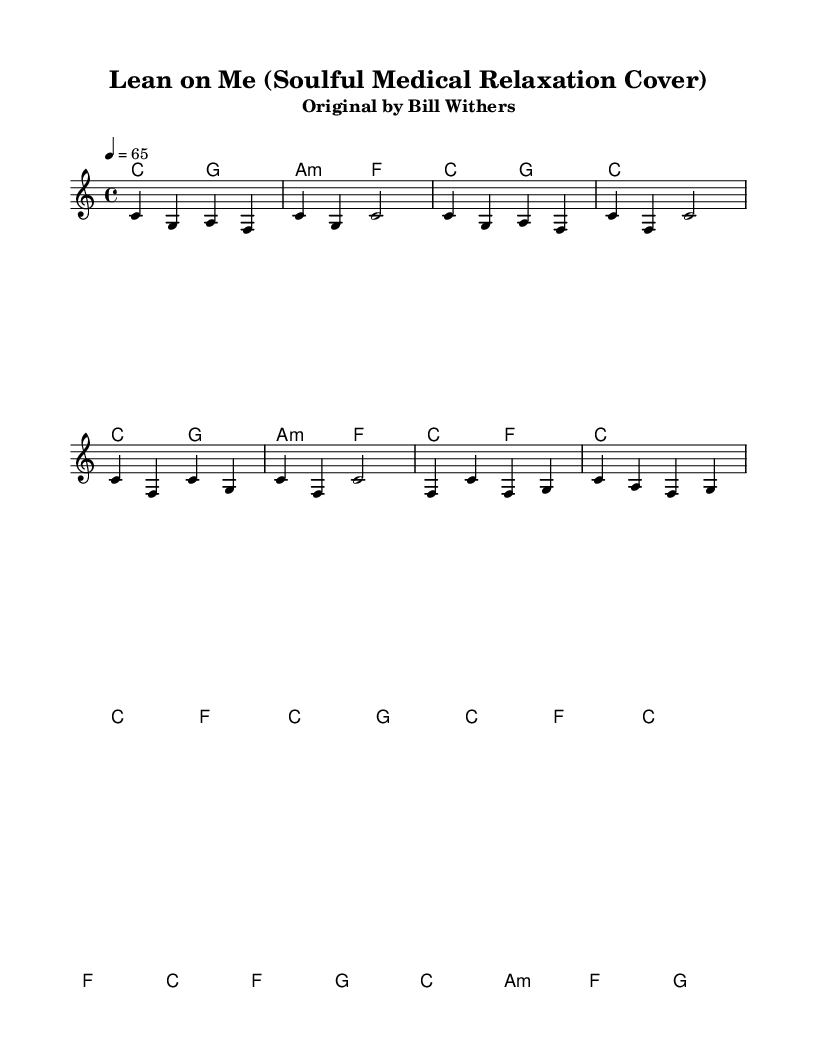What is the key signature of this music? The key signature indicated at the beginning of the score is C major, which contains no sharps or flats. This can be determined by looking for the key signature symbols, which in this case appear as an empty space.
Answer: C major What is the time signature of this music? The time signature is indicated as 4/4, meaning there are four beats in each measure and the quarter note gets one beat. This is usually found at the beginning of the score and is recognized by the two numbers stacked vertically.
Answer: 4/4 What is the tempo marking for this music? The tempo marking is indicated to be 4 = 65, which means the quarter note is to be played at a speed of 65 beats per minute. This can be identified in the tempo section of the score.
Answer: 65 What is the chord for the intro section? The chords for the intro section consist of C major and G major, followed by A minor and F major. Each chord is noted along the staff and indicates which harmonies support the melody.
Answer: C, G, A minor, F Which part of the song structure is represented by the bridge section? The bridge section is represented in the score by the measures that include transitions, usually appearing in a different rhythmic pattern or chord progression. It can be identified in the score where new harmonies or melodies are introduced, which differs from the verse and chorus.
Answer: Bridge What type of covers does this music represent? This music represents soulful covers, which are reimagined slower versions of popular songs, intended for relaxation. This is characterized by smooth melodies and gentle harmonies tailored for serene environments, especially in medical settings.
Answer: Soulful covers How is 'Lean on Me' categorized within the soul genre? 'Lean on Me' is categorized as a classic soul song, known for its uplifting message and emotional resonance, making it ideal for reinterpretation in a more relaxed style, as evidenced by the soulful covers approach taken in this arrangement.
Answer: Classic soul 